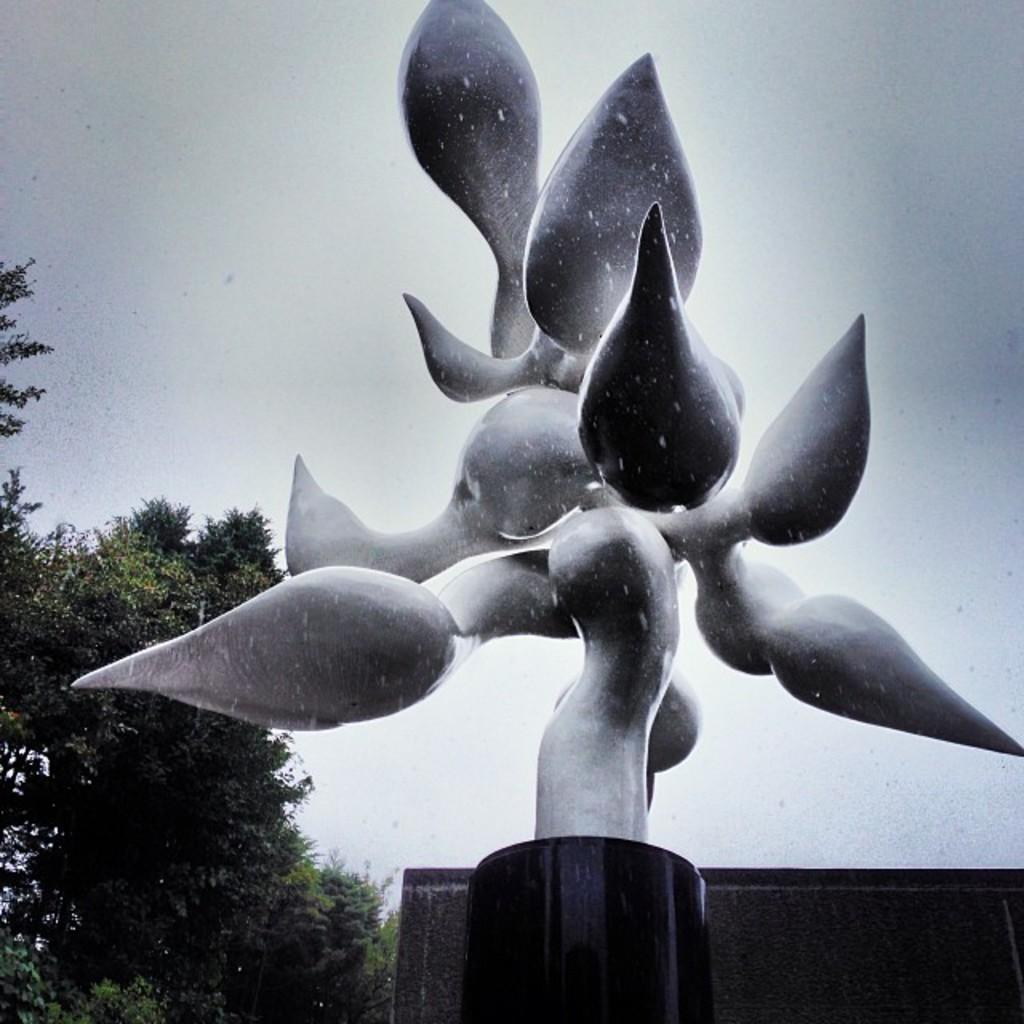What is the main subject in the image? There is a statue fountain in the image. What can be seen in the background of the image? The sky is visible behind the statue fountain. What type of vegetation is on the left side of the image? There are trees on the left side of the image. What type of wound can be seen on the statue in the image? There is no wound present on the statue in the image. What emotion does the statue express in the image? The statue is a non-living object and does not express emotions. 